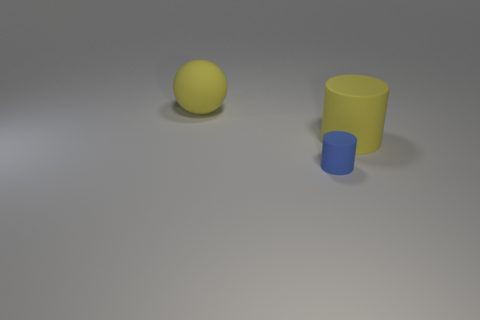What might be the texture of the objects depicted? The big yellow ball seems to have a smooth texture, while the tiny blue cylinder appears matte, indicating a non-reflective surface texture. 